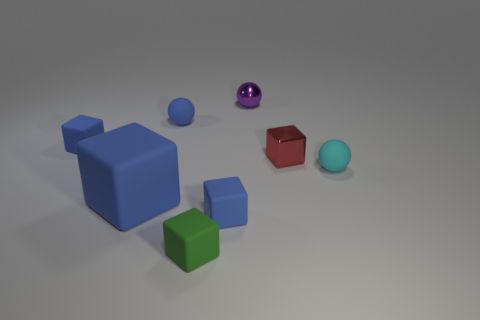Is the size of the matte sphere that is in front of the red shiny object the same as the tiny red block?
Offer a very short reply. Yes. What is the material of the red object that is the same size as the green cube?
Give a very brief answer. Metal. There is another red object that is the same shape as the large matte thing; what is its material?
Make the answer very short. Metal. How many other objects are the same size as the purple sphere?
Your answer should be compact. 6. How many other metal cubes are the same color as the shiny cube?
Your answer should be very brief. 0. The green object is what shape?
Your answer should be very brief. Cube. The matte block that is both to the left of the small blue ball and in front of the tiny cyan rubber object is what color?
Provide a short and direct response. Blue. What is the red block made of?
Your answer should be very brief. Metal. The small matte thing to the right of the tiny red object has what shape?
Provide a succinct answer. Sphere. There is a rubber ball that is the same size as the cyan object; what color is it?
Offer a very short reply. Blue. 